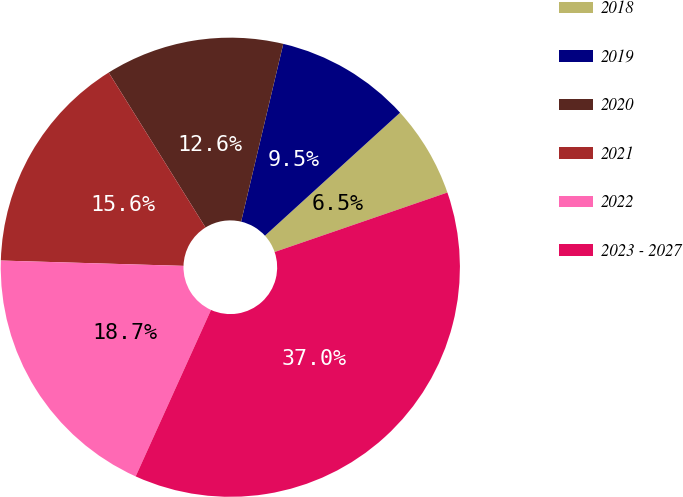Convert chart to OTSL. <chart><loc_0><loc_0><loc_500><loc_500><pie_chart><fcel>2018<fcel>2019<fcel>2020<fcel>2021<fcel>2022<fcel>2023 - 2027<nl><fcel>6.48%<fcel>9.54%<fcel>12.59%<fcel>15.65%<fcel>18.7%<fcel>37.04%<nl></chart> 